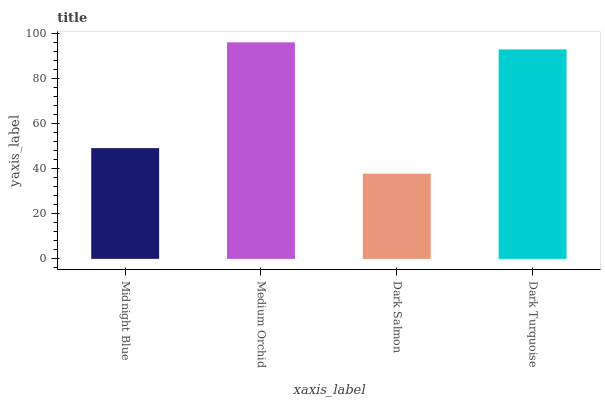Is Dark Salmon the minimum?
Answer yes or no. Yes. Is Medium Orchid the maximum?
Answer yes or no. Yes. Is Medium Orchid the minimum?
Answer yes or no. No. Is Dark Salmon the maximum?
Answer yes or no. No. Is Medium Orchid greater than Dark Salmon?
Answer yes or no. Yes. Is Dark Salmon less than Medium Orchid?
Answer yes or no. Yes. Is Dark Salmon greater than Medium Orchid?
Answer yes or no. No. Is Medium Orchid less than Dark Salmon?
Answer yes or no. No. Is Dark Turquoise the high median?
Answer yes or no. Yes. Is Midnight Blue the low median?
Answer yes or no. Yes. Is Dark Salmon the high median?
Answer yes or no. No. Is Dark Turquoise the low median?
Answer yes or no. No. 